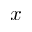Convert formula to latex. <formula><loc_0><loc_0><loc_500><loc_500>x</formula> 